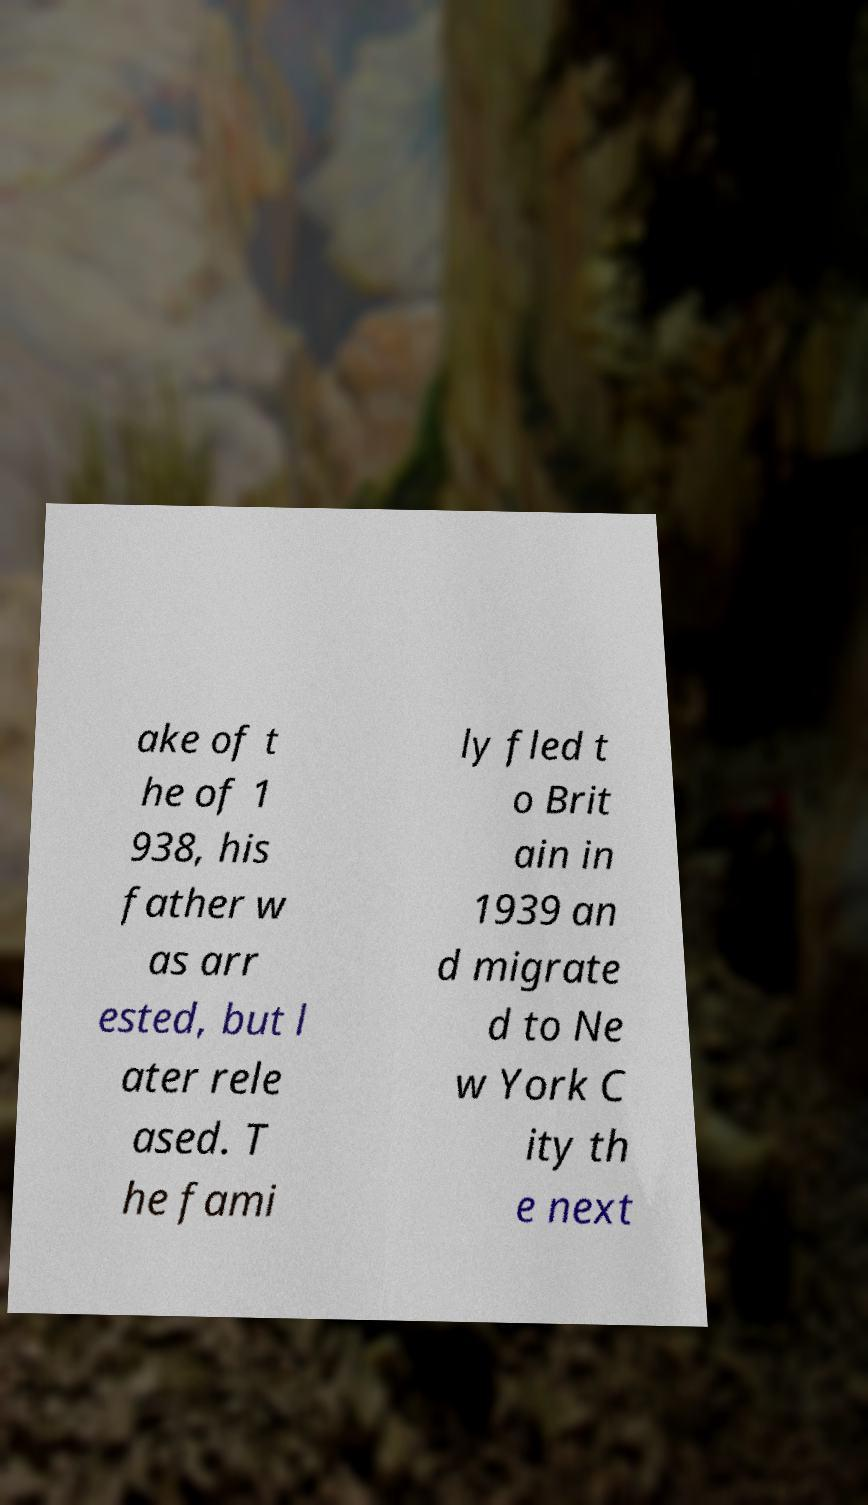For documentation purposes, I need the text within this image transcribed. Could you provide that? ake of t he of 1 938, his father w as arr ested, but l ater rele ased. T he fami ly fled t o Brit ain in 1939 an d migrate d to Ne w York C ity th e next 